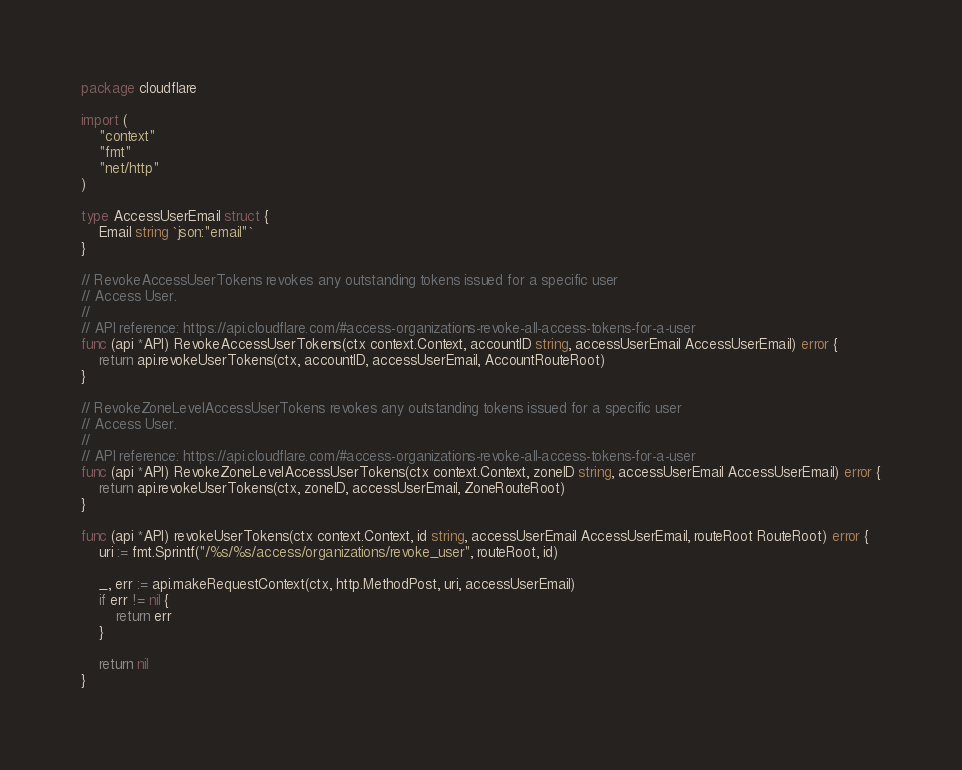Convert code to text. <code><loc_0><loc_0><loc_500><loc_500><_Go_>package cloudflare

import (
	"context"
	"fmt"
	"net/http"
)

type AccessUserEmail struct {
	Email string `json:"email"`
}

// RevokeAccessUserTokens revokes any outstanding tokens issued for a specific user
// Access User.
//
// API reference: https://api.cloudflare.com/#access-organizations-revoke-all-access-tokens-for-a-user
func (api *API) RevokeAccessUserTokens(ctx context.Context, accountID string, accessUserEmail AccessUserEmail) error {
	return api.revokeUserTokens(ctx, accountID, accessUserEmail, AccountRouteRoot)
}

// RevokeZoneLevelAccessUserTokens revokes any outstanding tokens issued for a specific user
// Access User.
//
// API reference: https://api.cloudflare.com/#access-organizations-revoke-all-access-tokens-for-a-user
func (api *API) RevokeZoneLevelAccessUserTokens(ctx context.Context, zoneID string, accessUserEmail AccessUserEmail) error {
	return api.revokeUserTokens(ctx, zoneID, accessUserEmail, ZoneRouteRoot)
}

func (api *API) revokeUserTokens(ctx context.Context, id string, accessUserEmail AccessUserEmail, routeRoot RouteRoot) error {
	uri := fmt.Sprintf("/%s/%s/access/organizations/revoke_user", routeRoot, id)

	_, err := api.makeRequestContext(ctx, http.MethodPost, uri, accessUserEmail)
	if err != nil {
		return err
	}

	return nil
}
</code> 